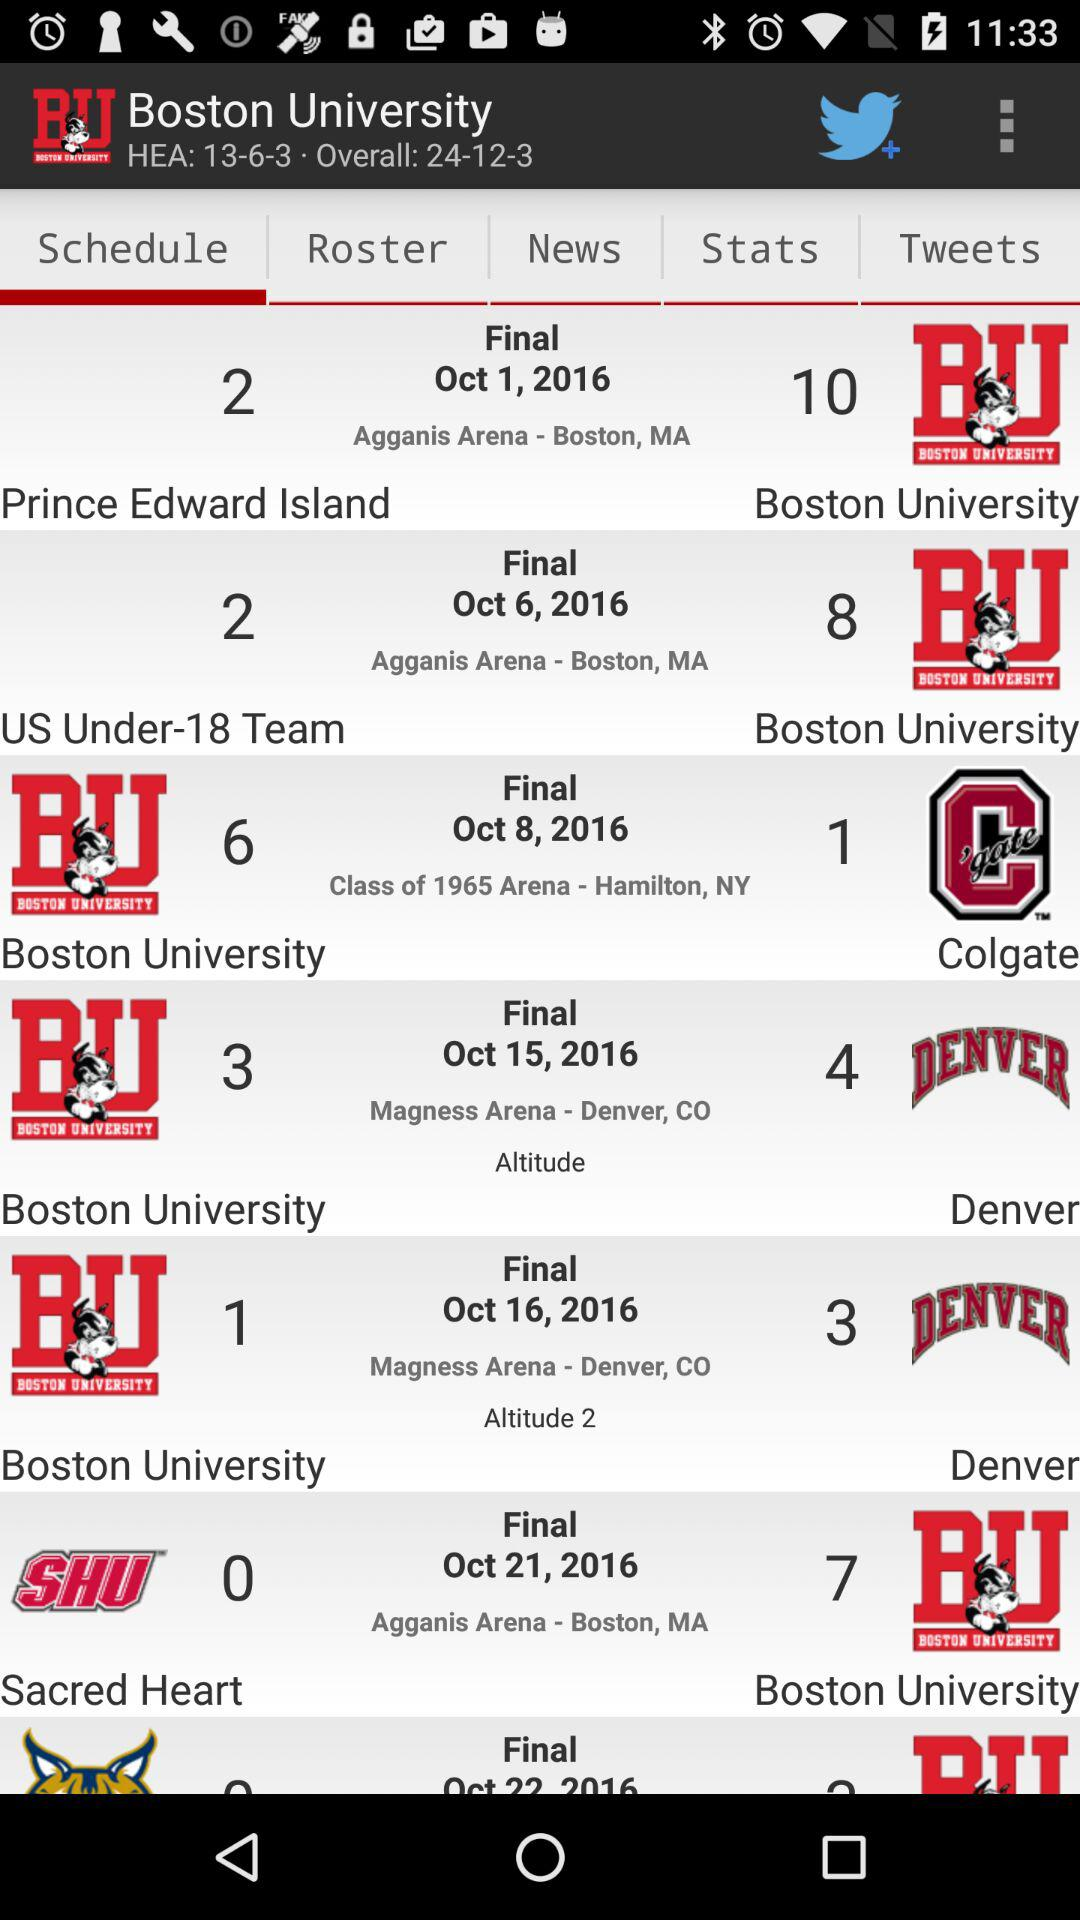What was the date of the "Denver" team's match that aired on "Altitude"? The date of the "Denver" team's match that aired on "Altitude" was October 15, 2016. 